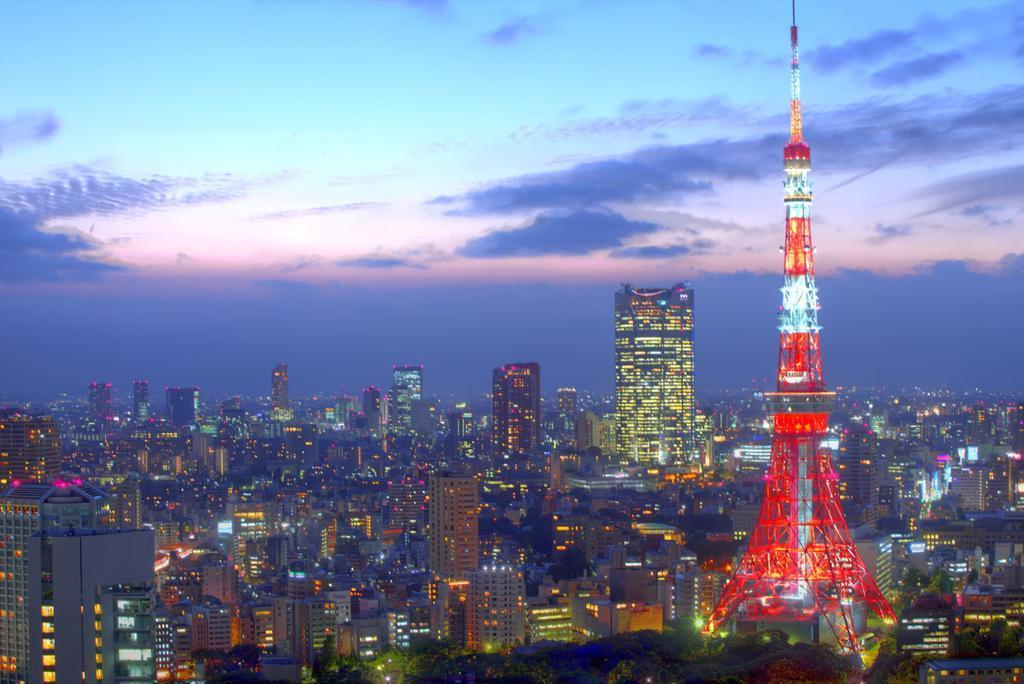In one or two sentences, can you explain what this image depicts? In this picture I can see the buildings in the middle. On the right side it looks like an Eiffel tower, at the top there is the sky. 